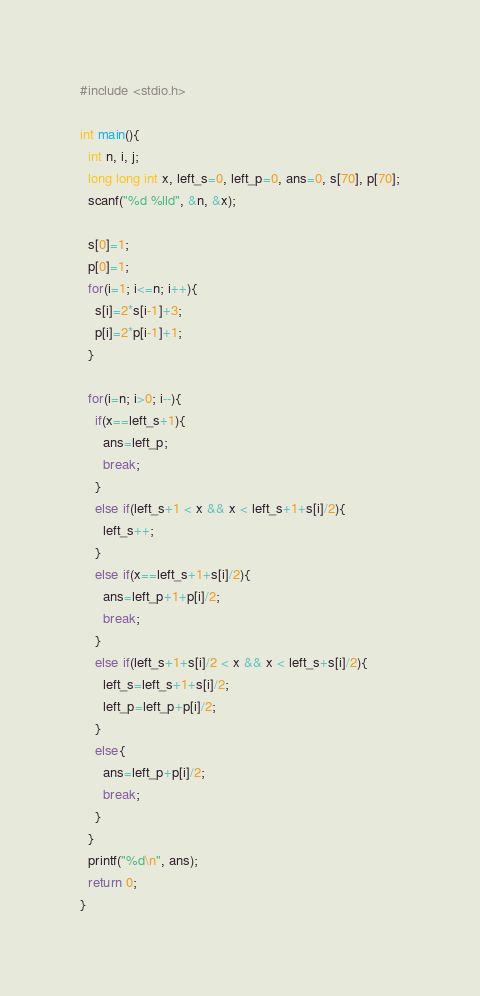Convert code to text. <code><loc_0><loc_0><loc_500><loc_500><_C_>#include <stdio.h>

int main(){
  int n, i, j;
  long long int x, left_s=0, left_p=0, ans=0, s[70], p[70];
  scanf("%d %lld", &n, &x);

  s[0]=1;
  p[0]=1;
  for(i=1; i<=n; i++){
    s[i]=2*s[i-1]+3;
    p[i]=2*p[i-1]+1;
  }

  for(i=n; i>0; i--){
    if(x==left_s+1){
      ans=left_p;
      break;
    }
    else if(left_s+1 < x && x < left_s+1+s[i]/2){
      left_s++;
    }
    else if(x==left_s+1+s[i]/2){
      ans=left_p+1+p[i]/2;
      break;
    }
    else if(left_s+1+s[i]/2 < x && x < left_s+s[i]/2){
      left_s=left_s+1+s[i]/2;
      left_p=left_p+p[i]/2;
    }
    else{
      ans=left_p+p[i]/2;
      break;
    }
  }
  printf("%d\n", ans);
  return 0;
}</code> 